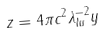<formula> <loc_0><loc_0><loc_500><loc_500>z = 4 \pi c ^ { 2 } \lambda ^ { - 2 } _ { l u } y</formula> 